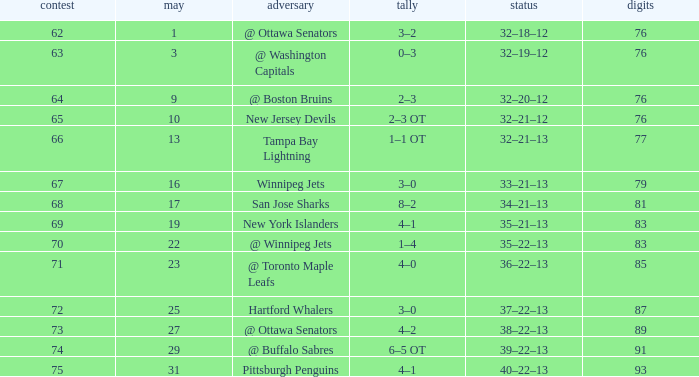How many games have a March of 19, and Points smaller than 83? 0.0. 